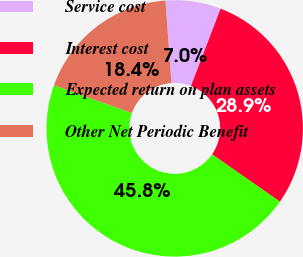Convert chart to OTSL. <chart><loc_0><loc_0><loc_500><loc_500><pie_chart><fcel>Service cost<fcel>Interest cost<fcel>Expected return on plan assets<fcel>Other Net Periodic Benefit<nl><fcel>6.98%<fcel>28.86%<fcel>45.77%<fcel>18.39%<nl></chart> 